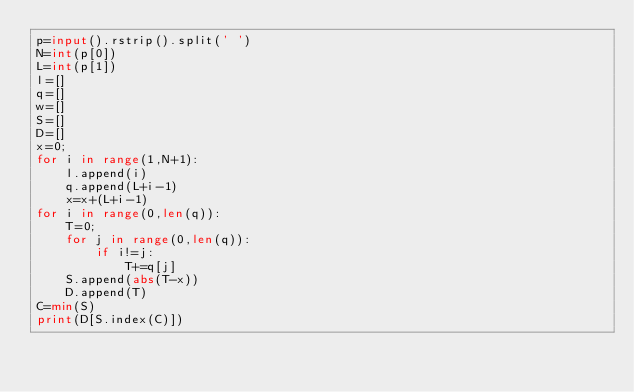<code> <loc_0><loc_0><loc_500><loc_500><_Python_>p=input().rstrip().split(' ')
N=int(p[0])
L=int(p[1])
l=[]
q=[]
w=[]
S=[]
D=[]
x=0;
for i in range(1,N+1):
    l.append(i)
    q.append(L+i-1)
    x=x+(L+i-1)
for i in range(0,len(q)):
    T=0;
    for j in range(0,len(q)):
        if i!=j:
            T+=q[j]
    S.append(abs(T-x))
    D.append(T)
C=min(S)
print(D[S.index(C)])
</code> 